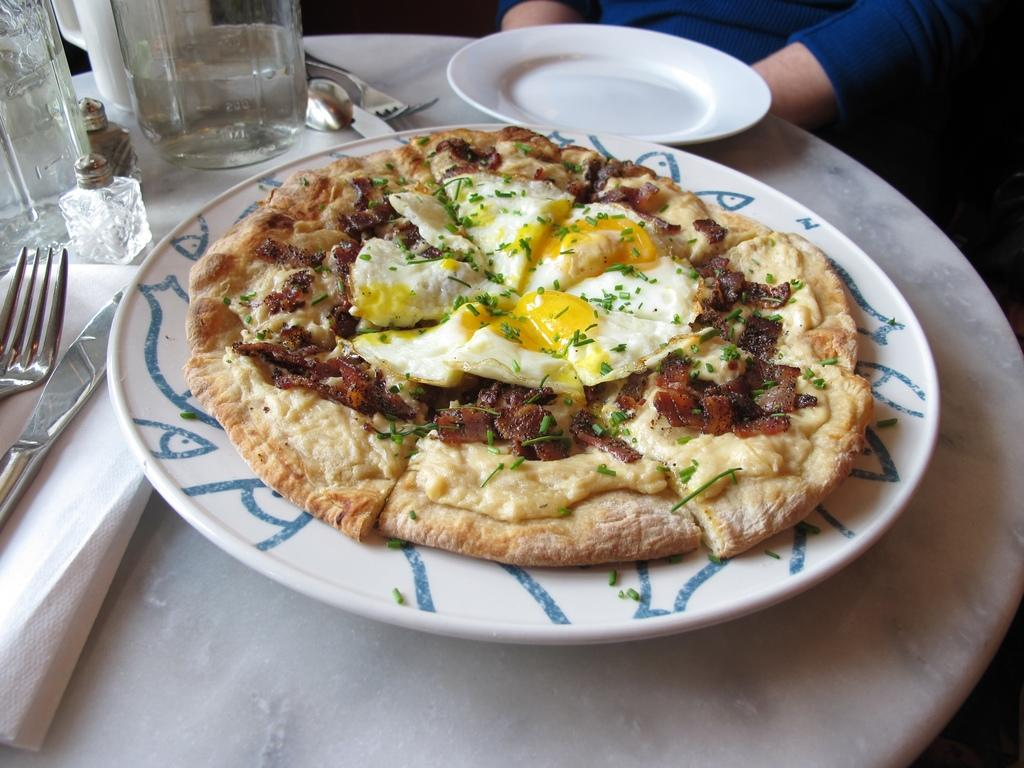What object is present on the table in the image? There is a plate in the image. What is on the plate? There is a food item on the plate. Can you describe the person in the image? There is a person sitting in the image. What type of cap is the person wearing in the image? There is no cap visible in the image; the person is not wearing one. How does the person's tongue appear in the image? The person's tongue is not visible in the image, so it cannot be described. 